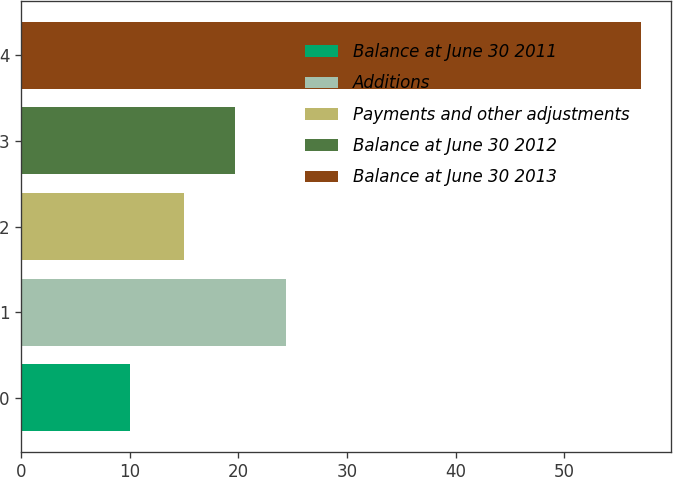Convert chart. <chart><loc_0><loc_0><loc_500><loc_500><bar_chart><fcel>Balance at June 30 2011<fcel>Additions<fcel>Payments and other adjustments<fcel>Balance at June 30 2012<fcel>Balance at June 30 2013<nl><fcel>10<fcel>24.4<fcel>15<fcel>19.7<fcel>57<nl></chart> 